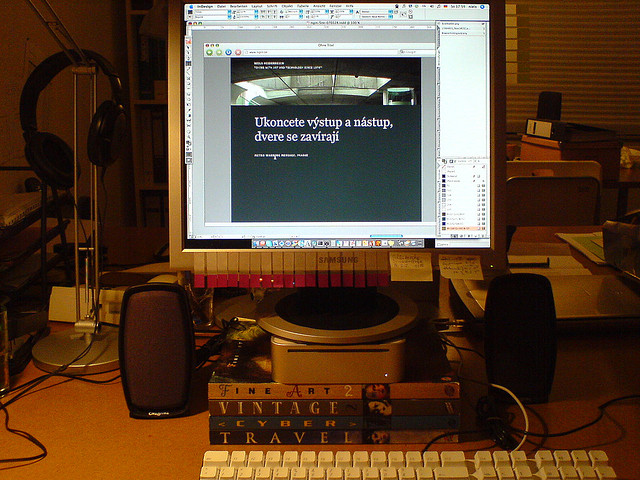<image>What word is to the right of System? I don't know what word is to the right of System, it might be 'vintage' or 'nastup' or there might be no word. What word is to the right of System? I don't know what word is to the right of System. It can be seen 'word', 'nothing', 'vintage', 'nastup', or 'vintage'. 